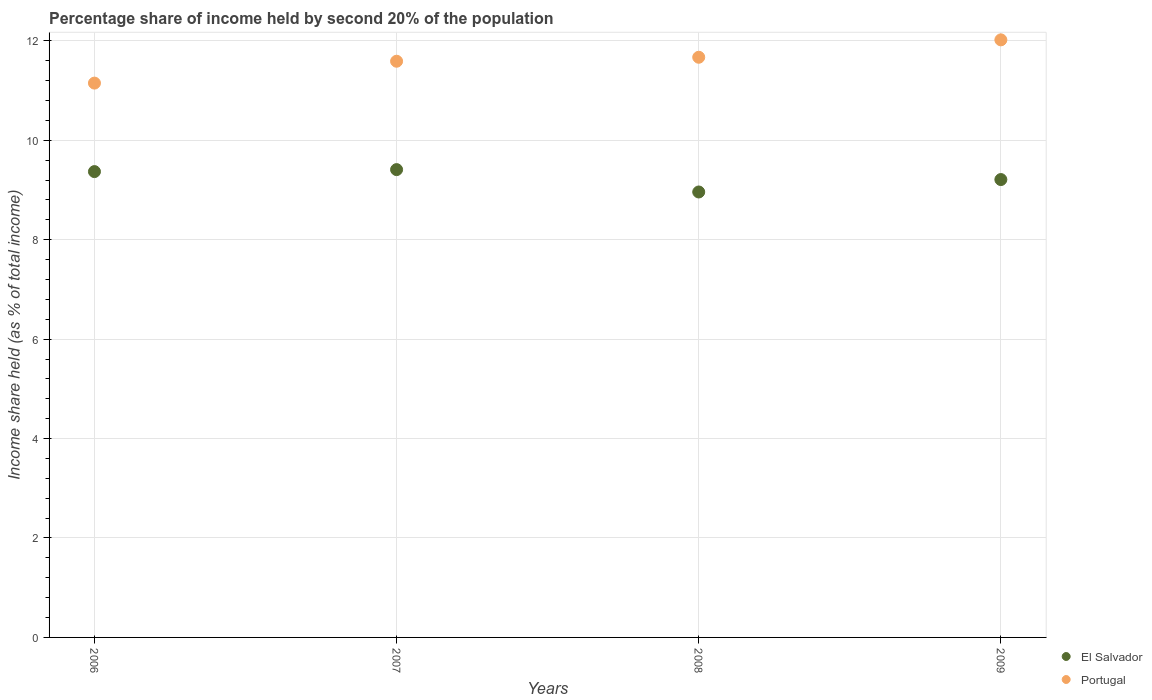How many different coloured dotlines are there?
Your answer should be compact. 2. What is the share of income held by second 20% of the population in El Salvador in 2009?
Provide a succinct answer. 9.21. Across all years, what is the maximum share of income held by second 20% of the population in El Salvador?
Keep it short and to the point. 9.41. Across all years, what is the minimum share of income held by second 20% of the population in Portugal?
Offer a very short reply. 11.15. In which year was the share of income held by second 20% of the population in Portugal minimum?
Your response must be concise. 2006. What is the total share of income held by second 20% of the population in Portugal in the graph?
Your answer should be compact. 46.43. What is the difference between the share of income held by second 20% of the population in Portugal in 2006 and that in 2009?
Offer a very short reply. -0.87. What is the difference between the share of income held by second 20% of the population in El Salvador in 2009 and the share of income held by second 20% of the population in Portugal in 2008?
Keep it short and to the point. -2.46. What is the average share of income held by second 20% of the population in El Salvador per year?
Make the answer very short. 9.24. In the year 2006, what is the difference between the share of income held by second 20% of the population in Portugal and share of income held by second 20% of the population in El Salvador?
Your response must be concise. 1.78. What is the ratio of the share of income held by second 20% of the population in El Salvador in 2008 to that in 2009?
Offer a very short reply. 0.97. Is the share of income held by second 20% of the population in El Salvador in 2007 less than that in 2009?
Give a very brief answer. No. What is the difference between the highest and the second highest share of income held by second 20% of the population in Portugal?
Keep it short and to the point. 0.35. What is the difference between the highest and the lowest share of income held by second 20% of the population in Portugal?
Your answer should be very brief. 0.87. In how many years, is the share of income held by second 20% of the population in Portugal greater than the average share of income held by second 20% of the population in Portugal taken over all years?
Your answer should be compact. 2. Does the share of income held by second 20% of the population in Portugal monotonically increase over the years?
Provide a succinct answer. Yes. Is the share of income held by second 20% of the population in Portugal strictly greater than the share of income held by second 20% of the population in El Salvador over the years?
Provide a succinct answer. Yes. Is the share of income held by second 20% of the population in El Salvador strictly less than the share of income held by second 20% of the population in Portugal over the years?
Give a very brief answer. Yes. How many dotlines are there?
Provide a short and direct response. 2. What is the difference between two consecutive major ticks on the Y-axis?
Your answer should be very brief. 2. Does the graph contain any zero values?
Keep it short and to the point. No. Where does the legend appear in the graph?
Offer a terse response. Bottom right. How are the legend labels stacked?
Provide a succinct answer. Vertical. What is the title of the graph?
Provide a short and direct response. Percentage share of income held by second 20% of the population. What is the label or title of the Y-axis?
Ensure brevity in your answer.  Income share held (as % of total income). What is the Income share held (as % of total income) in El Salvador in 2006?
Provide a short and direct response. 9.37. What is the Income share held (as % of total income) of Portugal in 2006?
Provide a short and direct response. 11.15. What is the Income share held (as % of total income) of El Salvador in 2007?
Make the answer very short. 9.41. What is the Income share held (as % of total income) of Portugal in 2007?
Your answer should be very brief. 11.59. What is the Income share held (as % of total income) of El Salvador in 2008?
Offer a very short reply. 8.96. What is the Income share held (as % of total income) of Portugal in 2008?
Offer a very short reply. 11.67. What is the Income share held (as % of total income) of El Salvador in 2009?
Your answer should be very brief. 9.21. What is the Income share held (as % of total income) of Portugal in 2009?
Keep it short and to the point. 12.02. Across all years, what is the maximum Income share held (as % of total income) in El Salvador?
Make the answer very short. 9.41. Across all years, what is the maximum Income share held (as % of total income) in Portugal?
Make the answer very short. 12.02. Across all years, what is the minimum Income share held (as % of total income) in El Salvador?
Offer a terse response. 8.96. Across all years, what is the minimum Income share held (as % of total income) of Portugal?
Your answer should be very brief. 11.15. What is the total Income share held (as % of total income) of El Salvador in the graph?
Give a very brief answer. 36.95. What is the total Income share held (as % of total income) of Portugal in the graph?
Offer a terse response. 46.43. What is the difference between the Income share held (as % of total income) of El Salvador in 2006 and that in 2007?
Ensure brevity in your answer.  -0.04. What is the difference between the Income share held (as % of total income) in Portugal in 2006 and that in 2007?
Keep it short and to the point. -0.44. What is the difference between the Income share held (as % of total income) in El Salvador in 2006 and that in 2008?
Provide a succinct answer. 0.41. What is the difference between the Income share held (as % of total income) in Portugal in 2006 and that in 2008?
Keep it short and to the point. -0.52. What is the difference between the Income share held (as % of total income) of El Salvador in 2006 and that in 2009?
Offer a terse response. 0.16. What is the difference between the Income share held (as % of total income) of Portugal in 2006 and that in 2009?
Ensure brevity in your answer.  -0.87. What is the difference between the Income share held (as % of total income) in El Salvador in 2007 and that in 2008?
Offer a terse response. 0.45. What is the difference between the Income share held (as % of total income) in Portugal in 2007 and that in 2008?
Keep it short and to the point. -0.08. What is the difference between the Income share held (as % of total income) in El Salvador in 2007 and that in 2009?
Ensure brevity in your answer.  0.2. What is the difference between the Income share held (as % of total income) in Portugal in 2007 and that in 2009?
Ensure brevity in your answer.  -0.43. What is the difference between the Income share held (as % of total income) of El Salvador in 2008 and that in 2009?
Give a very brief answer. -0.25. What is the difference between the Income share held (as % of total income) in Portugal in 2008 and that in 2009?
Make the answer very short. -0.35. What is the difference between the Income share held (as % of total income) of El Salvador in 2006 and the Income share held (as % of total income) of Portugal in 2007?
Provide a short and direct response. -2.22. What is the difference between the Income share held (as % of total income) of El Salvador in 2006 and the Income share held (as % of total income) of Portugal in 2009?
Give a very brief answer. -2.65. What is the difference between the Income share held (as % of total income) of El Salvador in 2007 and the Income share held (as % of total income) of Portugal in 2008?
Give a very brief answer. -2.26. What is the difference between the Income share held (as % of total income) in El Salvador in 2007 and the Income share held (as % of total income) in Portugal in 2009?
Your answer should be very brief. -2.61. What is the difference between the Income share held (as % of total income) in El Salvador in 2008 and the Income share held (as % of total income) in Portugal in 2009?
Offer a terse response. -3.06. What is the average Income share held (as % of total income) of El Salvador per year?
Offer a very short reply. 9.24. What is the average Income share held (as % of total income) in Portugal per year?
Provide a short and direct response. 11.61. In the year 2006, what is the difference between the Income share held (as % of total income) in El Salvador and Income share held (as % of total income) in Portugal?
Offer a very short reply. -1.78. In the year 2007, what is the difference between the Income share held (as % of total income) of El Salvador and Income share held (as % of total income) of Portugal?
Offer a terse response. -2.18. In the year 2008, what is the difference between the Income share held (as % of total income) in El Salvador and Income share held (as % of total income) in Portugal?
Keep it short and to the point. -2.71. In the year 2009, what is the difference between the Income share held (as % of total income) in El Salvador and Income share held (as % of total income) in Portugal?
Provide a succinct answer. -2.81. What is the ratio of the Income share held (as % of total income) of El Salvador in 2006 to that in 2008?
Your answer should be compact. 1.05. What is the ratio of the Income share held (as % of total income) of Portugal in 2006 to that in 2008?
Offer a terse response. 0.96. What is the ratio of the Income share held (as % of total income) in El Salvador in 2006 to that in 2009?
Keep it short and to the point. 1.02. What is the ratio of the Income share held (as % of total income) in Portugal in 2006 to that in 2009?
Ensure brevity in your answer.  0.93. What is the ratio of the Income share held (as % of total income) in El Salvador in 2007 to that in 2008?
Your response must be concise. 1.05. What is the ratio of the Income share held (as % of total income) of El Salvador in 2007 to that in 2009?
Provide a short and direct response. 1.02. What is the ratio of the Income share held (as % of total income) of Portugal in 2007 to that in 2009?
Your answer should be compact. 0.96. What is the ratio of the Income share held (as % of total income) in El Salvador in 2008 to that in 2009?
Your answer should be compact. 0.97. What is the ratio of the Income share held (as % of total income) in Portugal in 2008 to that in 2009?
Your answer should be very brief. 0.97. What is the difference between the highest and the second highest Income share held (as % of total income) in El Salvador?
Provide a succinct answer. 0.04. What is the difference between the highest and the second highest Income share held (as % of total income) of Portugal?
Provide a short and direct response. 0.35. What is the difference between the highest and the lowest Income share held (as % of total income) of El Salvador?
Your answer should be very brief. 0.45. What is the difference between the highest and the lowest Income share held (as % of total income) in Portugal?
Ensure brevity in your answer.  0.87. 